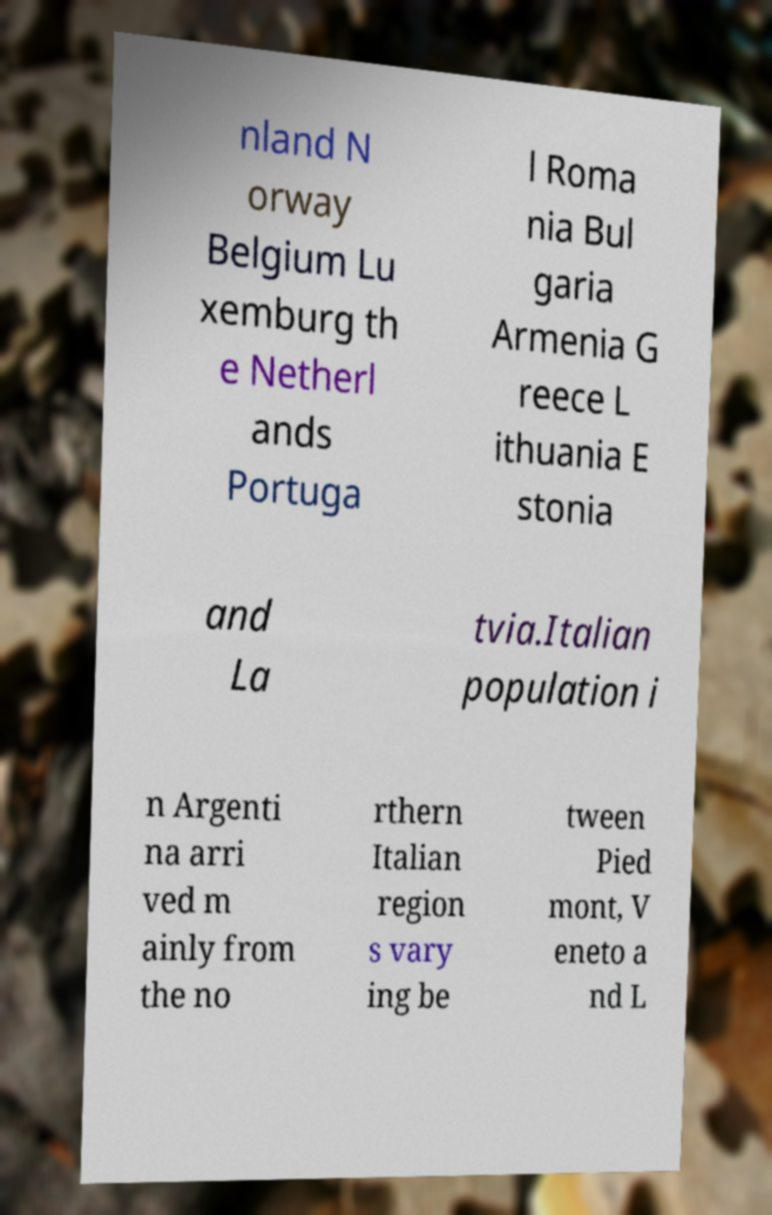Can you accurately transcribe the text from the provided image for me? nland N orway Belgium Lu xemburg th e Netherl ands Portuga l Roma nia Bul garia Armenia G reece L ithuania E stonia and La tvia.Italian population i n Argenti na arri ved m ainly from the no rthern Italian region s vary ing be tween Pied mont, V eneto a nd L 